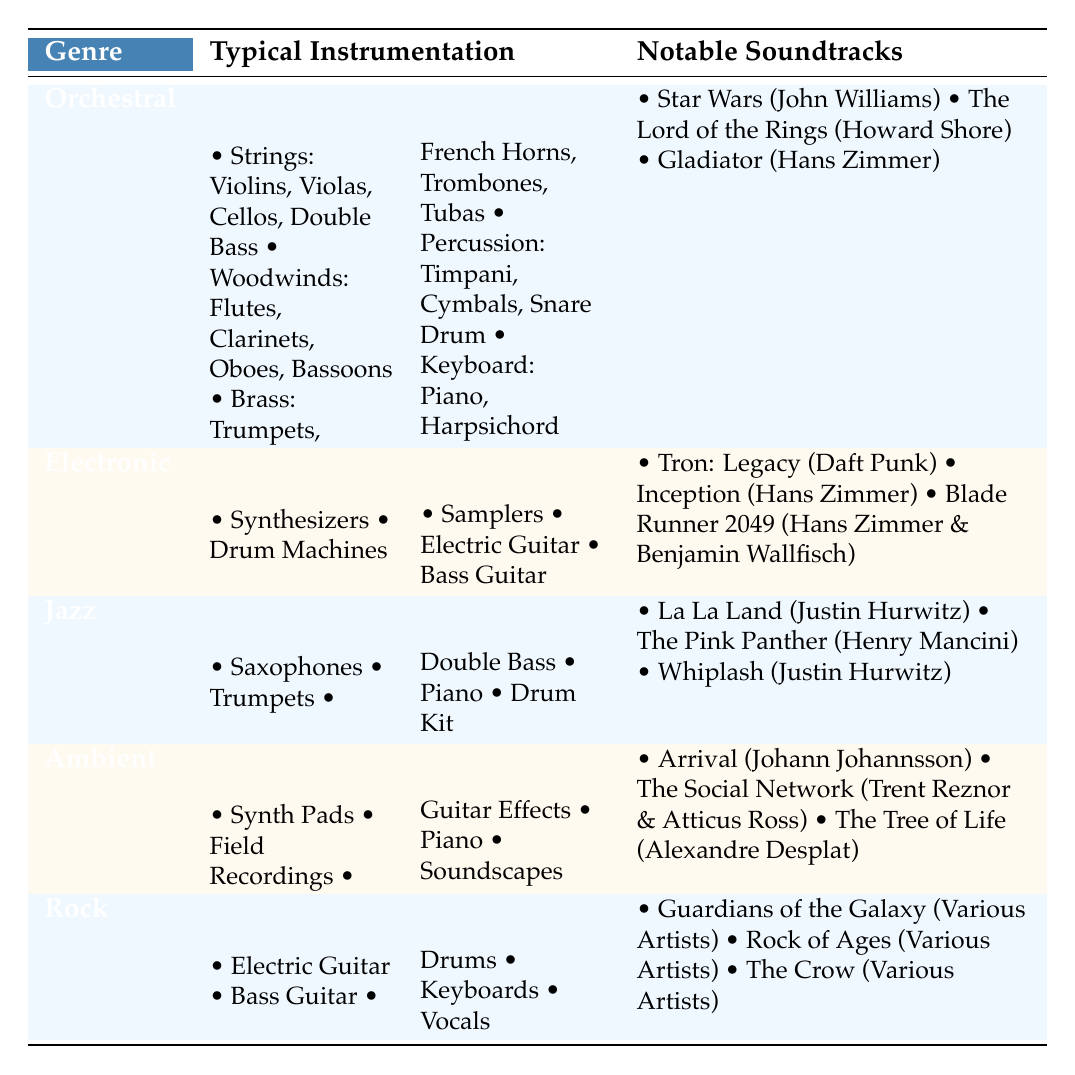What are the notable soundtracks associated with the Jazz genre? The table lists notable soundtracks under the Jazz genre, which are: La La Land (Justin Hurwitz), The Pink Panther (Henry Mancini), and Whiplash (Justin Hurwitz).
Answer: La La Land, The Pink Panther, Whiplash Which genre features Electric Guitar in its typical instrumentation? By examining the table, we see that both Electronic and Rock genres include Electric Guitar as part of their typical instrumentation.
Answer: Electronic and Rock Is it true that Orchestral genre includes Synthesizers in its instrumentation? Looking at the table, the Orchestral genre does not list Synthesizers in its typical instrumentation; these are found under Electronic and Ambient genres.
Answer: No How many notable soundtracks are listed for the Ambient genre? The Ambient genre has three notable soundtracks listed: Arrival (Johann Johannsson), The Social Network (Trent Reznor & Atticus Ross), and The Tree of Life (Alexandre Desplat). Thus, the count is 3.
Answer: 3 Which genre has the most diverse instrumentation based on the table? To determine the diversity, we can look at the number of different instruments listed. Orchestral has 5 types of instruments, Electronic has 5, Jazz has 5, Ambient has 5, and Rock has 5; therefore, all genres have equal diversity based on the list shown.
Answer: All genres are equal in diversity What is the sum of the number of instruments used in the Electronic and Ambient genres? The Electronic genre lists 5 instruments, and the Ambient genre also lists 5 instruments. By adding these, we get 5 + 5 = 10 total instruments across both genres.
Answer: 10 How many film scores were composed by Hans Zimmer that are mentioned in the table? From the table, Hans Zimmer is credited for two scores: Inception and Blade Runner 2049. Therefore, the total count of film scores associated with him is 2.
Answer: 2 Identify the genres that include Piano in their typical instrumentation. The genres that feature Piano in their instrumentation are Orchestral, Jazz, and Ambient, as stated in the table under each genre's typical instrumentation section.
Answer: Orchestral, Jazz, Ambient Which notable soundtrack corresponds with the Electronic genre that was composed by Hans Zimmer? When reviewing the notable soundtracks of the Electronic genre, Inception, composed by Hans Zimmer, is listed.
Answer: Inception 